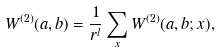<formula> <loc_0><loc_0><loc_500><loc_500>W ^ { ( 2 ) } ( a , b ) = \frac { 1 } { r ^ { l } } \sum _ { x } W ^ { ( 2 ) } ( a , b ; { x } ) ,</formula> 